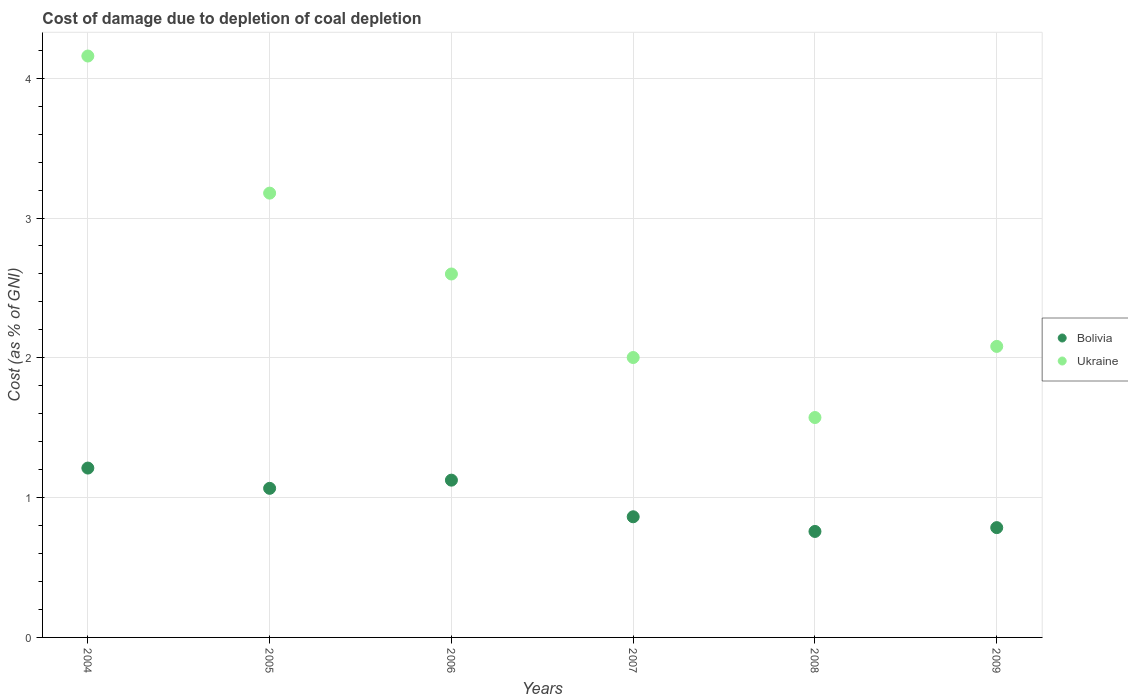Is the number of dotlines equal to the number of legend labels?
Make the answer very short. Yes. What is the cost of damage caused due to coal depletion in Ukraine in 2004?
Your response must be concise. 4.16. Across all years, what is the maximum cost of damage caused due to coal depletion in Ukraine?
Your response must be concise. 4.16. Across all years, what is the minimum cost of damage caused due to coal depletion in Ukraine?
Your answer should be very brief. 1.57. What is the total cost of damage caused due to coal depletion in Ukraine in the graph?
Keep it short and to the point. 15.59. What is the difference between the cost of damage caused due to coal depletion in Bolivia in 2007 and that in 2009?
Provide a succinct answer. 0.08. What is the difference between the cost of damage caused due to coal depletion in Ukraine in 2005 and the cost of damage caused due to coal depletion in Bolivia in 2007?
Give a very brief answer. 2.31. What is the average cost of damage caused due to coal depletion in Ukraine per year?
Ensure brevity in your answer.  2.6. In the year 2009, what is the difference between the cost of damage caused due to coal depletion in Bolivia and cost of damage caused due to coal depletion in Ukraine?
Ensure brevity in your answer.  -1.3. In how many years, is the cost of damage caused due to coal depletion in Bolivia greater than 1.8 %?
Ensure brevity in your answer.  0. What is the ratio of the cost of damage caused due to coal depletion in Bolivia in 2004 to that in 2007?
Offer a very short reply. 1.4. Is the cost of damage caused due to coal depletion in Ukraine in 2006 less than that in 2009?
Ensure brevity in your answer.  No. What is the difference between the highest and the second highest cost of damage caused due to coal depletion in Bolivia?
Your answer should be very brief. 0.09. What is the difference between the highest and the lowest cost of damage caused due to coal depletion in Bolivia?
Your response must be concise. 0.45. In how many years, is the cost of damage caused due to coal depletion in Ukraine greater than the average cost of damage caused due to coal depletion in Ukraine taken over all years?
Offer a terse response. 3. Is the sum of the cost of damage caused due to coal depletion in Ukraine in 2007 and 2009 greater than the maximum cost of damage caused due to coal depletion in Bolivia across all years?
Your response must be concise. Yes. Does the cost of damage caused due to coal depletion in Bolivia monotonically increase over the years?
Offer a terse response. No. How many dotlines are there?
Offer a very short reply. 2. Does the graph contain any zero values?
Make the answer very short. No. Where does the legend appear in the graph?
Keep it short and to the point. Center right. How many legend labels are there?
Offer a terse response. 2. What is the title of the graph?
Make the answer very short. Cost of damage due to depletion of coal depletion. Does "Dominica" appear as one of the legend labels in the graph?
Offer a very short reply. No. What is the label or title of the X-axis?
Your answer should be very brief. Years. What is the label or title of the Y-axis?
Give a very brief answer. Cost (as % of GNI). What is the Cost (as % of GNI) in Bolivia in 2004?
Give a very brief answer. 1.21. What is the Cost (as % of GNI) of Ukraine in 2004?
Ensure brevity in your answer.  4.16. What is the Cost (as % of GNI) of Bolivia in 2005?
Keep it short and to the point. 1.07. What is the Cost (as % of GNI) in Ukraine in 2005?
Your response must be concise. 3.18. What is the Cost (as % of GNI) in Bolivia in 2006?
Offer a terse response. 1.12. What is the Cost (as % of GNI) of Ukraine in 2006?
Give a very brief answer. 2.6. What is the Cost (as % of GNI) in Bolivia in 2007?
Offer a terse response. 0.86. What is the Cost (as % of GNI) in Ukraine in 2007?
Provide a succinct answer. 2. What is the Cost (as % of GNI) in Bolivia in 2008?
Your answer should be compact. 0.76. What is the Cost (as % of GNI) in Ukraine in 2008?
Make the answer very short. 1.57. What is the Cost (as % of GNI) in Bolivia in 2009?
Offer a very short reply. 0.79. What is the Cost (as % of GNI) of Ukraine in 2009?
Keep it short and to the point. 2.08. Across all years, what is the maximum Cost (as % of GNI) in Bolivia?
Provide a short and direct response. 1.21. Across all years, what is the maximum Cost (as % of GNI) of Ukraine?
Provide a succinct answer. 4.16. Across all years, what is the minimum Cost (as % of GNI) in Bolivia?
Offer a terse response. 0.76. Across all years, what is the minimum Cost (as % of GNI) in Ukraine?
Ensure brevity in your answer.  1.57. What is the total Cost (as % of GNI) in Bolivia in the graph?
Ensure brevity in your answer.  5.81. What is the total Cost (as % of GNI) of Ukraine in the graph?
Your answer should be very brief. 15.59. What is the difference between the Cost (as % of GNI) of Bolivia in 2004 and that in 2005?
Offer a very short reply. 0.14. What is the difference between the Cost (as % of GNI) of Ukraine in 2004 and that in 2005?
Your answer should be compact. 0.98. What is the difference between the Cost (as % of GNI) in Bolivia in 2004 and that in 2006?
Give a very brief answer. 0.09. What is the difference between the Cost (as % of GNI) of Ukraine in 2004 and that in 2006?
Offer a very short reply. 1.56. What is the difference between the Cost (as % of GNI) in Bolivia in 2004 and that in 2007?
Give a very brief answer. 0.35. What is the difference between the Cost (as % of GNI) in Ukraine in 2004 and that in 2007?
Your answer should be compact. 2.16. What is the difference between the Cost (as % of GNI) of Bolivia in 2004 and that in 2008?
Offer a very short reply. 0.45. What is the difference between the Cost (as % of GNI) in Ukraine in 2004 and that in 2008?
Give a very brief answer. 2.59. What is the difference between the Cost (as % of GNI) in Bolivia in 2004 and that in 2009?
Make the answer very short. 0.43. What is the difference between the Cost (as % of GNI) of Ukraine in 2004 and that in 2009?
Make the answer very short. 2.08. What is the difference between the Cost (as % of GNI) of Bolivia in 2005 and that in 2006?
Provide a short and direct response. -0.06. What is the difference between the Cost (as % of GNI) in Ukraine in 2005 and that in 2006?
Your answer should be compact. 0.58. What is the difference between the Cost (as % of GNI) in Bolivia in 2005 and that in 2007?
Give a very brief answer. 0.2. What is the difference between the Cost (as % of GNI) of Ukraine in 2005 and that in 2007?
Your answer should be very brief. 1.18. What is the difference between the Cost (as % of GNI) of Bolivia in 2005 and that in 2008?
Provide a short and direct response. 0.31. What is the difference between the Cost (as % of GNI) in Ukraine in 2005 and that in 2008?
Offer a very short reply. 1.6. What is the difference between the Cost (as % of GNI) in Bolivia in 2005 and that in 2009?
Provide a short and direct response. 0.28. What is the difference between the Cost (as % of GNI) of Ukraine in 2005 and that in 2009?
Your response must be concise. 1.1. What is the difference between the Cost (as % of GNI) of Bolivia in 2006 and that in 2007?
Ensure brevity in your answer.  0.26. What is the difference between the Cost (as % of GNI) of Ukraine in 2006 and that in 2007?
Ensure brevity in your answer.  0.6. What is the difference between the Cost (as % of GNI) in Bolivia in 2006 and that in 2008?
Your response must be concise. 0.37. What is the difference between the Cost (as % of GNI) in Ukraine in 2006 and that in 2008?
Provide a succinct answer. 1.03. What is the difference between the Cost (as % of GNI) of Bolivia in 2006 and that in 2009?
Provide a short and direct response. 0.34. What is the difference between the Cost (as % of GNI) in Ukraine in 2006 and that in 2009?
Offer a very short reply. 0.52. What is the difference between the Cost (as % of GNI) in Bolivia in 2007 and that in 2008?
Your response must be concise. 0.1. What is the difference between the Cost (as % of GNI) in Ukraine in 2007 and that in 2008?
Ensure brevity in your answer.  0.43. What is the difference between the Cost (as % of GNI) of Bolivia in 2007 and that in 2009?
Your answer should be compact. 0.08. What is the difference between the Cost (as % of GNI) of Ukraine in 2007 and that in 2009?
Offer a terse response. -0.08. What is the difference between the Cost (as % of GNI) of Bolivia in 2008 and that in 2009?
Your answer should be compact. -0.03. What is the difference between the Cost (as % of GNI) in Ukraine in 2008 and that in 2009?
Give a very brief answer. -0.51. What is the difference between the Cost (as % of GNI) of Bolivia in 2004 and the Cost (as % of GNI) of Ukraine in 2005?
Offer a terse response. -1.97. What is the difference between the Cost (as % of GNI) of Bolivia in 2004 and the Cost (as % of GNI) of Ukraine in 2006?
Your response must be concise. -1.39. What is the difference between the Cost (as % of GNI) of Bolivia in 2004 and the Cost (as % of GNI) of Ukraine in 2007?
Ensure brevity in your answer.  -0.79. What is the difference between the Cost (as % of GNI) of Bolivia in 2004 and the Cost (as % of GNI) of Ukraine in 2008?
Your answer should be very brief. -0.36. What is the difference between the Cost (as % of GNI) in Bolivia in 2004 and the Cost (as % of GNI) in Ukraine in 2009?
Keep it short and to the point. -0.87. What is the difference between the Cost (as % of GNI) in Bolivia in 2005 and the Cost (as % of GNI) in Ukraine in 2006?
Make the answer very short. -1.53. What is the difference between the Cost (as % of GNI) in Bolivia in 2005 and the Cost (as % of GNI) in Ukraine in 2007?
Give a very brief answer. -0.94. What is the difference between the Cost (as % of GNI) of Bolivia in 2005 and the Cost (as % of GNI) of Ukraine in 2008?
Offer a terse response. -0.51. What is the difference between the Cost (as % of GNI) in Bolivia in 2005 and the Cost (as % of GNI) in Ukraine in 2009?
Offer a very short reply. -1.02. What is the difference between the Cost (as % of GNI) in Bolivia in 2006 and the Cost (as % of GNI) in Ukraine in 2007?
Give a very brief answer. -0.88. What is the difference between the Cost (as % of GNI) in Bolivia in 2006 and the Cost (as % of GNI) in Ukraine in 2008?
Make the answer very short. -0.45. What is the difference between the Cost (as % of GNI) of Bolivia in 2006 and the Cost (as % of GNI) of Ukraine in 2009?
Provide a short and direct response. -0.96. What is the difference between the Cost (as % of GNI) in Bolivia in 2007 and the Cost (as % of GNI) in Ukraine in 2008?
Give a very brief answer. -0.71. What is the difference between the Cost (as % of GNI) in Bolivia in 2007 and the Cost (as % of GNI) in Ukraine in 2009?
Your response must be concise. -1.22. What is the difference between the Cost (as % of GNI) of Bolivia in 2008 and the Cost (as % of GNI) of Ukraine in 2009?
Ensure brevity in your answer.  -1.32. What is the average Cost (as % of GNI) in Bolivia per year?
Your answer should be very brief. 0.97. What is the average Cost (as % of GNI) of Ukraine per year?
Your response must be concise. 2.6. In the year 2004, what is the difference between the Cost (as % of GNI) in Bolivia and Cost (as % of GNI) in Ukraine?
Give a very brief answer. -2.95. In the year 2005, what is the difference between the Cost (as % of GNI) in Bolivia and Cost (as % of GNI) in Ukraine?
Your response must be concise. -2.11. In the year 2006, what is the difference between the Cost (as % of GNI) of Bolivia and Cost (as % of GNI) of Ukraine?
Keep it short and to the point. -1.47. In the year 2007, what is the difference between the Cost (as % of GNI) of Bolivia and Cost (as % of GNI) of Ukraine?
Ensure brevity in your answer.  -1.14. In the year 2008, what is the difference between the Cost (as % of GNI) of Bolivia and Cost (as % of GNI) of Ukraine?
Your answer should be very brief. -0.81. In the year 2009, what is the difference between the Cost (as % of GNI) of Bolivia and Cost (as % of GNI) of Ukraine?
Make the answer very short. -1.3. What is the ratio of the Cost (as % of GNI) of Bolivia in 2004 to that in 2005?
Make the answer very short. 1.14. What is the ratio of the Cost (as % of GNI) of Ukraine in 2004 to that in 2005?
Provide a short and direct response. 1.31. What is the ratio of the Cost (as % of GNI) of Bolivia in 2004 to that in 2006?
Provide a short and direct response. 1.08. What is the ratio of the Cost (as % of GNI) of Ukraine in 2004 to that in 2006?
Keep it short and to the point. 1.6. What is the ratio of the Cost (as % of GNI) in Bolivia in 2004 to that in 2007?
Offer a very short reply. 1.4. What is the ratio of the Cost (as % of GNI) in Ukraine in 2004 to that in 2007?
Offer a terse response. 2.08. What is the ratio of the Cost (as % of GNI) of Bolivia in 2004 to that in 2008?
Give a very brief answer. 1.6. What is the ratio of the Cost (as % of GNI) in Ukraine in 2004 to that in 2008?
Ensure brevity in your answer.  2.64. What is the ratio of the Cost (as % of GNI) in Bolivia in 2004 to that in 2009?
Keep it short and to the point. 1.54. What is the ratio of the Cost (as % of GNI) in Ukraine in 2004 to that in 2009?
Your answer should be compact. 2. What is the ratio of the Cost (as % of GNI) of Bolivia in 2005 to that in 2006?
Offer a terse response. 0.95. What is the ratio of the Cost (as % of GNI) of Ukraine in 2005 to that in 2006?
Make the answer very short. 1.22. What is the ratio of the Cost (as % of GNI) in Bolivia in 2005 to that in 2007?
Keep it short and to the point. 1.24. What is the ratio of the Cost (as % of GNI) of Ukraine in 2005 to that in 2007?
Ensure brevity in your answer.  1.59. What is the ratio of the Cost (as % of GNI) in Bolivia in 2005 to that in 2008?
Give a very brief answer. 1.41. What is the ratio of the Cost (as % of GNI) in Ukraine in 2005 to that in 2008?
Your answer should be very brief. 2.02. What is the ratio of the Cost (as % of GNI) of Bolivia in 2005 to that in 2009?
Keep it short and to the point. 1.36. What is the ratio of the Cost (as % of GNI) of Ukraine in 2005 to that in 2009?
Ensure brevity in your answer.  1.53. What is the ratio of the Cost (as % of GNI) in Bolivia in 2006 to that in 2007?
Offer a terse response. 1.3. What is the ratio of the Cost (as % of GNI) of Ukraine in 2006 to that in 2007?
Provide a short and direct response. 1.3. What is the ratio of the Cost (as % of GNI) in Bolivia in 2006 to that in 2008?
Provide a succinct answer. 1.48. What is the ratio of the Cost (as % of GNI) of Ukraine in 2006 to that in 2008?
Keep it short and to the point. 1.65. What is the ratio of the Cost (as % of GNI) of Bolivia in 2006 to that in 2009?
Your answer should be very brief. 1.43. What is the ratio of the Cost (as % of GNI) of Ukraine in 2006 to that in 2009?
Offer a very short reply. 1.25. What is the ratio of the Cost (as % of GNI) in Bolivia in 2007 to that in 2008?
Give a very brief answer. 1.14. What is the ratio of the Cost (as % of GNI) of Ukraine in 2007 to that in 2008?
Ensure brevity in your answer.  1.27. What is the ratio of the Cost (as % of GNI) in Bolivia in 2007 to that in 2009?
Keep it short and to the point. 1.1. What is the ratio of the Cost (as % of GNI) of Ukraine in 2007 to that in 2009?
Make the answer very short. 0.96. What is the ratio of the Cost (as % of GNI) of Bolivia in 2008 to that in 2009?
Your answer should be very brief. 0.97. What is the ratio of the Cost (as % of GNI) of Ukraine in 2008 to that in 2009?
Give a very brief answer. 0.76. What is the difference between the highest and the second highest Cost (as % of GNI) of Bolivia?
Offer a terse response. 0.09. What is the difference between the highest and the second highest Cost (as % of GNI) of Ukraine?
Provide a succinct answer. 0.98. What is the difference between the highest and the lowest Cost (as % of GNI) of Bolivia?
Provide a short and direct response. 0.45. What is the difference between the highest and the lowest Cost (as % of GNI) of Ukraine?
Provide a short and direct response. 2.59. 